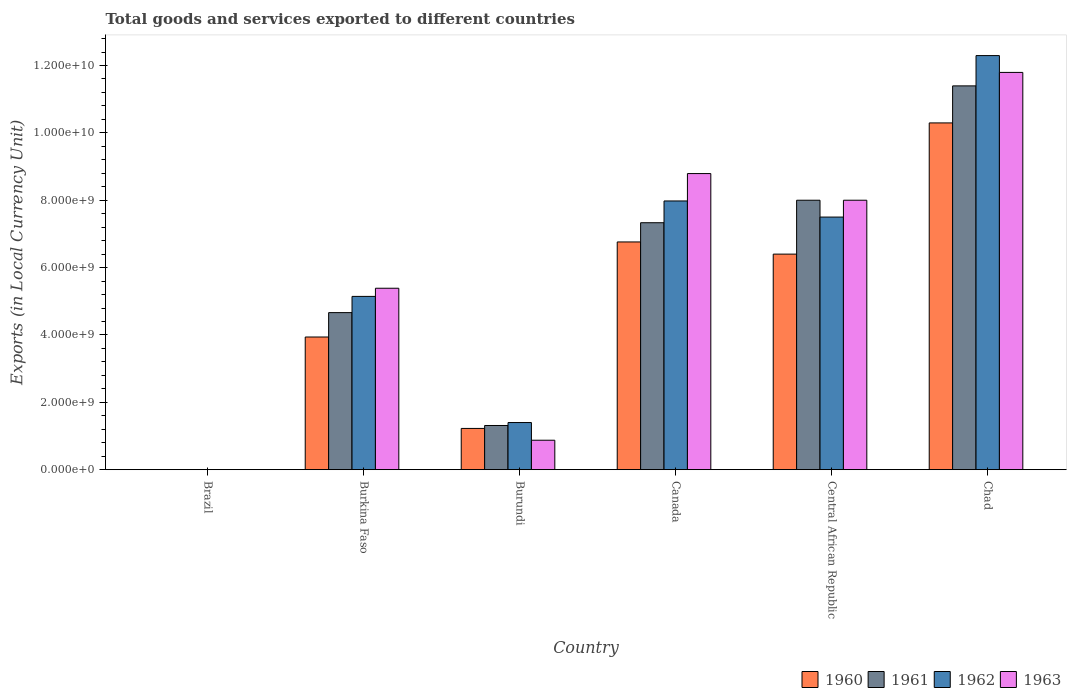How many groups of bars are there?
Give a very brief answer. 6. How many bars are there on the 4th tick from the left?
Give a very brief answer. 4. What is the label of the 2nd group of bars from the left?
Provide a succinct answer. Burkina Faso. What is the Amount of goods and services exports in 1962 in Burkina Faso?
Make the answer very short. 5.14e+09. Across all countries, what is the maximum Amount of goods and services exports in 1961?
Ensure brevity in your answer.  1.14e+1. Across all countries, what is the minimum Amount of goods and services exports in 1960?
Your answer should be compact. 7.27491e-5. In which country was the Amount of goods and services exports in 1962 maximum?
Make the answer very short. Chad. What is the total Amount of goods and services exports in 1963 in the graph?
Ensure brevity in your answer.  3.48e+1. What is the difference between the Amount of goods and services exports in 1963 in Burundi and that in Canada?
Keep it short and to the point. -7.92e+09. What is the difference between the Amount of goods and services exports in 1962 in Canada and the Amount of goods and services exports in 1963 in Burkina Faso?
Give a very brief answer. 2.59e+09. What is the average Amount of goods and services exports in 1963 per country?
Make the answer very short. 5.81e+09. What is the difference between the Amount of goods and services exports of/in 1960 and Amount of goods and services exports of/in 1961 in Canada?
Provide a succinct answer. -5.71e+08. What is the ratio of the Amount of goods and services exports in 1963 in Burkina Faso to that in Burundi?
Your answer should be compact. 6.16. Is the difference between the Amount of goods and services exports in 1960 in Canada and Chad greater than the difference between the Amount of goods and services exports in 1961 in Canada and Chad?
Your answer should be very brief. Yes. What is the difference between the highest and the second highest Amount of goods and services exports in 1961?
Your answer should be very brief. 6.68e+08. What is the difference between the highest and the lowest Amount of goods and services exports in 1960?
Your answer should be compact. 1.03e+1. Is it the case that in every country, the sum of the Amount of goods and services exports in 1961 and Amount of goods and services exports in 1963 is greater than the sum of Amount of goods and services exports in 1960 and Amount of goods and services exports in 1962?
Make the answer very short. No. Is it the case that in every country, the sum of the Amount of goods and services exports in 1961 and Amount of goods and services exports in 1963 is greater than the Amount of goods and services exports in 1960?
Make the answer very short. Yes. How many countries are there in the graph?
Give a very brief answer. 6. What is the difference between two consecutive major ticks on the Y-axis?
Your response must be concise. 2.00e+09. Does the graph contain any zero values?
Offer a very short reply. No. Where does the legend appear in the graph?
Keep it short and to the point. Bottom right. What is the title of the graph?
Your response must be concise. Total goods and services exported to different countries. What is the label or title of the Y-axis?
Your response must be concise. Exports (in Local Currency Unit). What is the Exports (in Local Currency Unit) in 1960 in Brazil?
Your answer should be compact. 7.27491e-5. What is the Exports (in Local Currency Unit) of 1961 in Brazil?
Offer a terse response. 0. What is the Exports (in Local Currency Unit) of 1962 in Brazil?
Your answer should be compact. 0. What is the Exports (in Local Currency Unit) of 1963 in Brazil?
Give a very brief answer. 0. What is the Exports (in Local Currency Unit) in 1960 in Burkina Faso?
Your response must be concise. 3.94e+09. What is the Exports (in Local Currency Unit) in 1961 in Burkina Faso?
Your response must be concise. 4.66e+09. What is the Exports (in Local Currency Unit) in 1962 in Burkina Faso?
Your response must be concise. 5.14e+09. What is the Exports (in Local Currency Unit) in 1963 in Burkina Faso?
Your answer should be compact. 5.39e+09. What is the Exports (in Local Currency Unit) in 1960 in Burundi?
Your response must be concise. 1.22e+09. What is the Exports (in Local Currency Unit) of 1961 in Burundi?
Ensure brevity in your answer.  1.31e+09. What is the Exports (in Local Currency Unit) of 1962 in Burundi?
Give a very brief answer. 1.40e+09. What is the Exports (in Local Currency Unit) in 1963 in Burundi?
Keep it short and to the point. 8.75e+08. What is the Exports (in Local Currency Unit) of 1960 in Canada?
Offer a very short reply. 6.76e+09. What is the Exports (in Local Currency Unit) of 1961 in Canada?
Provide a short and direct response. 7.33e+09. What is the Exports (in Local Currency Unit) of 1962 in Canada?
Your answer should be compact. 7.98e+09. What is the Exports (in Local Currency Unit) in 1963 in Canada?
Give a very brief answer. 8.79e+09. What is the Exports (in Local Currency Unit) of 1960 in Central African Republic?
Give a very brief answer. 6.40e+09. What is the Exports (in Local Currency Unit) in 1961 in Central African Republic?
Your response must be concise. 8.00e+09. What is the Exports (in Local Currency Unit) of 1962 in Central African Republic?
Give a very brief answer. 7.50e+09. What is the Exports (in Local Currency Unit) of 1963 in Central African Republic?
Offer a very short reply. 8.00e+09. What is the Exports (in Local Currency Unit) of 1960 in Chad?
Make the answer very short. 1.03e+1. What is the Exports (in Local Currency Unit) in 1961 in Chad?
Provide a succinct answer. 1.14e+1. What is the Exports (in Local Currency Unit) of 1962 in Chad?
Provide a short and direct response. 1.23e+1. What is the Exports (in Local Currency Unit) in 1963 in Chad?
Provide a succinct answer. 1.18e+1. Across all countries, what is the maximum Exports (in Local Currency Unit) of 1960?
Provide a short and direct response. 1.03e+1. Across all countries, what is the maximum Exports (in Local Currency Unit) of 1961?
Give a very brief answer. 1.14e+1. Across all countries, what is the maximum Exports (in Local Currency Unit) of 1962?
Make the answer very short. 1.23e+1. Across all countries, what is the maximum Exports (in Local Currency Unit) of 1963?
Keep it short and to the point. 1.18e+1. Across all countries, what is the minimum Exports (in Local Currency Unit) of 1960?
Provide a succinct answer. 7.27491e-5. Across all countries, what is the minimum Exports (in Local Currency Unit) of 1961?
Give a very brief answer. 0. Across all countries, what is the minimum Exports (in Local Currency Unit) in 1962?
Keep it short and to the point. 0. Across all countries, what is the minimum Exports (in Local Currency Unit) of 1963?
Make the answer very short. 0. What is the total Exports (in Local Currency Unit) in 1960 in the graph?
Keep it short and to the point. 2.86e+1. What is the total Exports (in Local Currency Unit) in 1961 in the graph?
Offer a very short reply. 3.27e+1. What is the total Exports (in Local Currency Unit) in 1962 in the graph?
Make the answer very short. 3.43e+1. What is the total Exports (in Local Currency Unit) in 1963 in the graph?
Offer a terse response. 3.48e+1. What is the difference between the Exports (in Local Currency Unit) in 1960 in Brazil and that in Burkina Faso?
Offer a terse response. -3.94e+09. What is the difference between the Exports (in Local Currency Unit) in 1961 in Brazil and that in Burkina Faso?
Ensure brevity in your answer.  -4.66e+09. What is the difference between the Exports (in Local Currency Unit) in 1962 in Brazil and that in Burkina Faso?
Your answer should be very brief. -5.14e+09. What is the difference between the Exports (in Local Currency Unit) in 1963 in Brazil and that in Burkina Faso?
Give a very brief answer. -5.39e+09. What is the difference between the Exports (in Local Currency Unit) in 1960 in Brazil and that in Burundi?
Make the answer very short. -1.22e+09. What is the difference between the Exports (in Local Currency Unit) of 1961 in Brazil and that in Burundi?
Your answer should be very brief. -1.31e+09. What is the difference between the Exports (in Local Currency Unit) of 1962 in Brazil and that in Burundi?
Provide a short and direct response. -1.40e+09. What is the difference between the Exports (in Local Currency Unit) of 1963 in Brazil and that in Burundi?
Your answer should be very brief. -8.75e+08. What is the difference between the Exports (in Local Currency Unit) in 1960 in Brazil and that in Canada?
Your answer should be very brief. -6.76e+09. What is the difference between the Exports (in Local Currency Unit) of 1961 in Brazil and that in Canada?
Keep it short and to the point. -7.33e+09. What is the difference between the Exports (in Local Currency Unit) of 1962 in Brazil and that in Canada?
Ensure brevity in your answer.  -7.98e+09. What is the difference between the Exports (in Local Currency Unit) in 1963 in Brazil and that in Canada?
Make the answer very short. -8.79e+09. What is the difference between the Exports (in Local Currency Unit) of 1960 in Brazil and that in Central African Republic?
Your response must be concise. -6.40e+09. What is the difference between the Exports (in Local Currency Unit) in 1961 in Brazil and that in Central African Republic?
Ensure brevity in your answer.  -8.00e+09. What is the difference between the Exports (in Local Currency Unit) of 1962 in Brazil and that in Central African Republic?
Your answer should be very brief. -7.50e+09. What is the difference between the Exports (in Local Currency Unit) of 1963 in Brazil and that in Central African Republic?
Offer a very short reply. -8.00e+09. What is the difference between the Exports (in Local Currency Unit) of 1960 in Brazil and that in Chad?
Your answer should be compact. -1.03e+1. What is the difference between the Exports (in Local Currency Unit) in 1961 in Brazil and that in Chad?
Keep it short and to the point. -1.14e+1. What is the difference between the Exports (in Local Currency Unit) in 1962 in Brazil and that in Chad?
Make the answer very short. -1.23e+1. What is the difference between the Exports (in Local Currency Unit) in 1963 in Brazil and that in Chad?
Provide a succinct answer. -1.18e+1. What is the difference between the Exports (in Local Currency Unit) of 1960 in Burkina Faso and that in Burundi?
Make the answer very short. 2.71e+09. What is the difference between the Exports (in Local Currency Unit) of 1961 in Burkina Faso and that in Burundi?
Keep it short and to the point. 3.35e+09. What is the difference between the Exports (in Local Currency Unit) of 1962 in Burkina Faso and that in Burundi?
Ensure brevity in your answer.  3.74e+09. What is the difference between the Exports (in Local Currency Unit) in 1963 in Burkina Faso and that in Burundi?
Provide a succinct answer. 4.51e+09. What is the difference between the Exports (in Local Currency Unit) in 1960 in Burkina Faso and that in Canada?
Make the answer very short. -2.82e+09. What is the difference between the Exports (in Local Currency Unit) of 1961 in Burkina Faso and that in Canada?
Keep it short and to the point. -2.67e+09. What is the difference between the Exports (in Local Currency Unit) in 1962 in Burkina Faso and that in Canada?
Your answer should be very brief. -2.83e+09. What is the difference between the Exports (in Local Currency Unit) of 1963 in Burkina Faso and that in Canada?
Provide a short and direct response. -3.40e+09. What is the difference between the Exports (in Local Currency Unit) of 1960 in Burkina Faso and that in Central African Republic?
Make the answer very short. -2.46e+09. What is the difference between the Exports (in Local Currency Unit) in 1961 in Burkina Faso and that in Central African Republic?
Your response must be concise. -3.34e+09. What is the difference between the Exports (in Local Currency Unit) in 1962 in Burkina Faso and that in Central African Republic?
Provide a short and direct response. -2.36e+09. What is the difference between the Exports (in Local Currency Unit) in 1963 in Burkina Faso and that in Central African Republic?
Provide a succinct answer. -2.61e+09. What is the difference between the Exports (in Local Currency Unit) of 1960 in Burkina Faso and that in Chad?
Give a very brief answer. -6.36e+09. What is the difference between the Exports (in Local Currency Unit) of 1961 in Burkina Faso and that in Chad?
Ensure brevity in your answer.  -6.73e+09. What is the difference between the Exports (in Local Currency Unit) of 1962 in Burkina Faso and that in Chad?
Offer a terse response. -7.15e+09. What is the difference between the Exports (in Local Currency Unit) in 1963 in Burkina Faso and that in Chad?
Keep it short and to the point. -6.41e+09. What is the difference between the Exports (in Local Currency Unit) of 1960 in Burundi and that in Canada?
Your answer should be compact. -5.54e+09. What is the difference between the Exports (in Local Currency Unit) of 1961 in Burundi and that in Canada?
Ensure brevity in your answer.  -6.02e+09. What is the difference between the Exports (in Local Currency Unit) of 1962 in Burundi and that in Canada?
Offer a very short reply. -6.58e+09. What is the difference between the Exports (in Local Currency Unit) of 1963 in Burundi and that in Canada?
Ensure brevity in your answer.  -7.92e+09. What is the difference between the Exports (in Local Currency Unit) in 1960 in Burundi and that in Central African Republic?
Provide a short and direct response. -5.18e+09. What is the difference between the Exports (in Local Currency Unit) in 1961 in Burundi and that in Central African Republic?
Make the answer very short. -6.69e+09. What is the difference between the Exports (in Local Currency Unit) of 1962 in Burundi and that in Central African Republic?
Offer a very short reply. -6.10e+09. What is the difference between the Exports (in Local Currency Unit) in 1963 in Burundi and that in Central African Republic?
Your answer should be very brief. -7.12e+09. What is the difference between the Exports (in Local Currency Unit) of 1960 in Burundi and that in Chad?
Make the answer very short. -9.07e+09. What is the difference between the Exports (in Local Currency Unit) in 1961 in Burundi and that in Chad?
Offer a very short reply. -1.01e+1. What is the difference between the Exports (in Local Currency Unit) in 1962 in Burundi and that in Chad?
Your answer should be very brief. -1.09e+1. What is the difference between the Exports (in Local Currency Unit) in 1963 in Burundi and that in Chad?
Provide a short and direct response. -1.09e+1. What is the difference between the Exports (in Local Currency Unit) of 1960 in Canada and that in Central African Republic?
Your response must be concise. 3.61e+08. What is the difference between the Exports (in Local Currency Unit) in 1961 in Canada and that in Central African Republic?
Give a very brief answer. -6.68e+08. What is the difference between the Exports (in Local Currency Unit) of 1962 in Canada and that in Central African Republic?
Give a very brief answer. 4.78e+08. What is the difference between the Exports (in Local Currency Unit) in 1963 in Canada and that in Central African Republic?
Keep it short and to the point. 7.91e+08. What is the difference between the Exports (in Local Currency Unit) in 1960 in Canada and that in Chad?
Ensure brevity in your answer.  -3.53e+09. What is the difference between the Exports (in Local Currency Unit) of 1961 in Canada and that in Chad?
Give a very brief answer. -4.06e+09. What is the difference between the Exports (in Local Currency Unit) of 1962 in Canada and that in Chad?
Give a very brief answer. -4.32e+09. What is the difference between the Exports (in Local Currency Unit) of 1963 in Canada and that in Chad?
Your answer should be very brief. -3.00e+09. What is the difference between the Exports (in Local Currency Unit) in 1960 in Central African Republic and that in Chad?
Give a very brief answer. -3.90e+09. What is the difference between the Exports (in Local Currency Unit) of 1961 in Central African Republic and that in Chad?
Give a very brief answer. -3.39e+09. What is the difference between the Exports (in Local Currency Unit) of 1962 in Central African Republic and that in Chad?
Your answer should be very brief. -4.79e+09. What is the difference between the Exports (in Local Currency Unit) in 1963 in Central African Republic and that in Chad?
Ensure brevity in your answer.  -3.79e+09. What is the difference between the Exports (in Local Currency Unit) in 1960 in Brazil and the Exports (in Local Currency Unit) in 1961 in Burkina Faso?
Provide a short and direct response. -4.66e+09. What is the difference between the Exports (in Local Currency Unit) of 1960 in Brazil and the Exports (in Local Currency Unit) of 1962 in Burkina Faso?
Offer a terse response. -5.14e+09. What is the difference between the Exports (in Local Currency Unit) of 1960 in Brazil and the Exports (in Local Currency Unit) of 1963 in Burkina Faso?
Make the answer very short. -5.39e+09. What is the difference between the Exports (in Local Currency Unit) of 1961 in Brazil and the Exports (in Local Currency Unit) of 1962 in Burkina Faso?
Offer a terse response. -5.14e+09. What is the difference between the Exports (in Local Currency Unit) in 1961 in Brazil and the Exports (in Local Currency Unit) in 1963 in Burkina Faso?
Your answer should be very brief. -5.39e+09. What is the difference between the Exports (in Local Currency Unit) of 1962 in Brazil and the Exports (in Local Currency Unit) of 1963 in Burkina Faso?
Provide a succinct answer. -5.39e+09. What is the difference between the Exports (in Local Currency Unit) of 1960 in Brazil and the Exports (in Local Currency Unit) of 1961 in Burundi?
Ensure brevity in your answer.  -1.31e+09. What is the difference between the Exports (in Local Currency Unit) in 1960 in Brazil and the Exports (in Local Currency Unit) in 1962 in Burundi?
Offer a very short reply. -1.40e+09. What is the difference between the Exports (in Local Currency Unit) of 1960 in Brazil and the Exports (in Local Currency Unit) of 1963 in Burundi?
Keep it short and to the point. -8.75e+08. What is the difference between the Exports (in Local Currency Unit) in 1961 in Brazil and the Exports (in Local Currency Unit) in 1962 in Burundi?
Provide a short and direct response. -1.40e+09. What is the difference between the Exports (in Local Currency Unit) of 1961 in Brazil and the Exports (in Local Currency Unit) of 1963 in Burundi?
Offer a terse response. -8.75e+08. What is the difference between the Exports (in Local Currency Unit) in 1962 in Brazil and the Exports (in Local Currency Unit) in 1963 in Burundi?
Offer a very short reply. -8.75e+08. What is the difference between the Exports (in Local Currency Unit) of 1960 in Brazil and the Exports (in Local Currency Unit) of 1961 in Canada?
Your response must be concise. -7.33e+09. What is the difference between the Exports (in Local Currency Unit) in 1960 in Brazil and the Exports (in Local Currency Unit) in 1962 in Canada?
Your answer should be compact. -7.98e+09. What is the difference between the Exports (in Local Currency Unit) in 1960 in Brazil and the Exports (in Local Currency Unit) in 1963 in Canada?
Give a very brief answer. -8.79e+09. What is the difference between the Exports (in Local Currency Unit) in 1961 in Brazil and the Exports (in Local Currency Unit) in 1962 in Canada?
Offer a terse response. -7.98e+09. What is the difference between the Exports (in Local Currency Unit) of 1961 in Brazil and the Exports (in Local Currency Unit) of 1963 in Canada?
Your answer should be compact. -8.79e+09. What is the difference between the Exports (in Local Currency Unit) in 1962 in Brazil and the Exports (in Local Currency Unit) in 1963 in Canada?
Make the answer very short. -8.79e+09. What is the difference between the Exports (in Local Currency Unit) of 1960 in Brazil and the Exports (in Local Currency Unit) of 1961 in Central African Republic?
Ensure brevity in your answer.  -8.00e+09. What is the difference between the Exports (in Local Currency Unit) of 1960 in Brazil and the Exports (in Local Currency Unit) of 1962 in Central African Republic?
Offer a terse response. -7.50e+09. What is the difference between the Exports (in Local Currency Unit) of 1960 in Brazil and the Exports (in Local Currency Unit) of 1963 in Central African Republic?
Keep it short and to the point. -8.00e+09. What is the difference between the Exports (in Local Currency Unit) in 1961 in Brazil and the Exports (in Local Currency Unit) in 1962 in Central African Republic?
Make the answer very short. -7.50e+09. What is the difference between the Exports (in Local Currency Unit) of 1961 in Brazil and the Exports (in Local Currency Unit) of 1963 in Central African Republic?
Offer a very short reply. -8.00e+09. What is the difference between the Exports (in Local Currency Unit) in 1962 in Brazil and the Exports (in Local Currency Unit) in 1963 in Central African Republic?
Offer a very short reply. -8.00e+09. What is the difference between the Exports (in Local Currency Unit) of 1960 in Brazil and the Exports (in Local Currency Unit) of 1961 in Chad?
Offer a very short reply. -1.14e+1. What is the difference between the Exports (in Local Currency Unit) of 1960 in Brazil and the Exports (in Local Currency Unit) of 1962 in Chad?
Keep it short and to the point. -1.23e+1. What is the difference between the Exports (in Local Currency Unit) in 1960 in Brazil and the Exports (in Local Currency Unit) in 1963 in Chad?
Provide a succinct answer. -1.18e+1. What is the difference between the Exports (in Local Currency Unit) of 1961 in Brazil and the Exports (in Local Currency Unit) of 1962 in Chad?
Make the answer very short. -1.23e+1. What is the difference between the Exports (in Local Currency Unit) in 1961 in Brazil and the Exports (in Local Currency Unit) in 1963 in Chad?
Ensure brevity in your answer.  -1.18e+1. What is the difference between the Exports (in Local Currency Unit) of 1962 in Brazil and the Exports (in Local Currency Unit) of 1963 in Chad?
Provide a short and direct response. -1.18e+1. What is the difference between the Exports (in Local Currency Unit) in 1960 in Burkina Faso and the Exports (in Local Currency Unit) in 1961 in Burundi?
Your response must be concise. 2.63e+09. What is the difference between the Exports (in Local Currency Unit) in 1960 in Burkina Faso and the Exports (in Local Currency Unit) in 1962 in Burundi?
Your answer should be compact. 2.54e+09. What is the difference between the Exports (in Local Currency Unit) in 1960 in Burkina Faso and the Exports (in Local Currency Unit) in 1963 in Burundi?
Give a very brief answer. 3.06e+09. What is the difference between the Exports (in Local Currency Unit) of 1961 in Burkina Faso and the Exports (in Local Currency Unit) of 1962 in Burundi?
Your answer should be compact. 3.26e+09. What is the difference between the Exports (in Local Currency Unit) in 1961 in Burkina Faso and the Exports (in Local Currency Unit) in 1963 in Burundi?
Keep it short and to the point. 3.79e+09. What is the difference between the Exports (in Local Currency Unit) of 1962 in Burkina Faso and the Exports (in Local Currency Unit) of 1963 in Burundi?
Your response must be concise. 4.27e+09. What is the difference between the Exports (in Local Currency Unit) of 1960 in Burkina Faso and the Exports (in Local Currency Unit) of 1961 in Canada?
Keep it short and to the point. -3.39e+09. What is the difference between the Exports (in Local Currency Unit) in 1960 in Burkina Faso and the Exports (in Local Currency Unit) in 1962 in Canada?
Provide a succinct answer. -4.04e+09. What is the difference between the Exports (in Local Currency Unit) in 1960 in Burkina Faso and the Exports (in Local Currency Unit) in 1963 in Canada?
Ensure brevity in your answer.  -4.85e+09. What is the difference between the Exports (in Local Currency Unit) in 1961 in Burkina Faso and the Exports (in Local Currency Unit) in 1962 in Canada?
Give a very brief answer. -3.31e+09. What is the difference between the Exports (in Local Currency Unit) of 1961 in Burkina Faso and the Exports (in Local Currency Unit) of 1963 in Canada?
Your response must be concise. -4.13e+09. What is the difference between the Exports (in Local Currency Unit) in 1962 in Burkina Faso and the Exports (in Local Currency Unit) in 1963 in Canada?
Offer a terse response. -3.65e+09. What is the difference between the Exports (in Local Currency Unit) of 1960 in Burkina Faso and the Exports (in Local Currency Unit) of 1961 in Central African Republic?
Offer a terse response. -4.06e+09. What is the difference between the Exports (in Local Currency Unit) of 1960 in Burkina Faso and the Exports (in Local Currency Unit) of 1962 in Central African Republic?
Offer a very short reply. -3.56e+09. What is the difference between the Exports (in Local Currency Unit) of 1960 in Burkina Faso and the Exports (in Local Currency Unit) of 1963 in Central African Republic?
Offer a very short reply. -4.06e+09. What is the difference between the Exports (in Local Currency Unit) of 1961 in Burkina Faso and the Exports (in Local Currency Unit) of 1962 in Central African Republic?
Make the answer very short. -2.84e+09. What is the difference between the Exports (in Local Currency Unit) of 1961 in Burkina Faso and the Exports (in Local Currency Unit) of 1963 in Central African Republic?
Make the answer very short. -3.34e+09. What is the difference between the Exports (in Local Currency Unit) of 1962 in Burkina Faso and the Exports (in Local Currency Unit) of 1963 in Central African Republic?
Make the answer very short. -2.86e+09. What is the difference between the Exports (in Local Currency Unit) in 1960 in Burkina Faso and the Exports (in Local Currency Unit) in 1961 in Chad?
Make the answer very short. -7.46e+09. What is the difference between the Exports (in Local Currency Unit) of 1960 in Burkina Faso and the Exports (in Local Currency Unit) of 1962 in Chad?
Offer a very short reply. -8.35e+09. What is the difference between the Exports (in Local Currency Unit) in 1960 in Burkina Faso and the Exports (in Local Currency Unit) in 1963 in Chad?
Make the answer very short. -7.86e+09. What is the difference between the Exports (in Local Currency Unit) in 1961 in Burkina Faso and the Exports (in Local Currency Unit) in 1962 in Chad?
Your answer should be very brief. -7.63e+09. What is the difference between the Exports (in Local Currency Unit) in 1961 in Burkina Faso and the Exports (in Local Currency Unit) in 1963 in Chad?
Offer a terse response. -7.13e+09. What is the difference between the Exports (in Local Currency Unit) of 1962 in Burkina Faso and the Exports (in Local Currency Unit) of 1963 in Chad?
Your answer should be compact. -6.65e+09. What is the difference between the Exports (in Local Currency Unit) of 1960 in Burundi and the Exports (in Local Currency Unit) of 1961 in Canada?
Give a very brief answer. -6.11e+09. What is the difference between the Exports (in Local Currency Unit) in 1960 in Burundi and the Exports (in Local Currency Unit) in 1962 in Canada?
Offer a very short reply. -6.75e+09. What is the difference between the Exports (in Local Currency Unit) of 1960 in Burundi and the Exports (in Local Currency Unit) of 1963 in Canada?
Ensure brevity in your answer.  -7.57e+09. What is the difference between the Exports (in Local Currency Unit) in 1961 in Burundi and the Exports (in Local Currency Unit) in 1962 in Canada?
Keep it short and to the point. -6.67e+09. What is the difference between the Exports (in Local Currency Unit) of 1961 in Burundi and the Exports (in Local Currency Unit) of 1963 in Canada?
Give a very brief answer. -7.48e+09. What is the difference between the Exports (in Local Currency Unit) in 1962 in Burundi and the Exports (in Local Currency Unit) in 1963 in Canada?
Your response must be concise. -7.39e+09. What is the difference between the Exports (in Local Currency Unit) of 1960 in Burundi and the Exports (in Local Currency Unit) of 1961 in Central African Republic?
Provide a short and direct response. -6.78e+09. What is the difference between the Exports (in Local Currency Unit) of 1960 in Burundi and the Exports (in Local Currency Unit) of 1962 in Central African Republic?
Your answer should be compact. -6.28e+09. What is the difference between the Exports (in Local Currency Unit) in 1960 in Burundi and the Exports (in Local Currency Unit) in 1963 in Central African Republic?
Your answer should be compact. -6.78e+09. What is the difference between the Exports (in Local Currency Unit) of 1961 in Burundi and the Exports (in Local Currency Unit) of 1962 in Central African Republic?
Your response must be concise. -6.19e+09. What is the difference between the Exports (in Local Currency Unit) of 1961 in Burundi and the Exports (in Local Currency Unit) of 1963 in Central African Republic?
Provide a short and direct response. -6.69e+09. What is the difference between the Exports (in Local Currency Unit) of 1962 in Burundi and the Exports (in Local Currency Unit) of 1963 in Central African Republic?
Make the answer very short. -6.60e+09. What is the difference between the Exports (in Local Currency Unit) in 1960 in Burundi and the Exports (in Local Currency Unit) in 1961 in Chad?
Make the answer very short. -1.02e+1. What is the difference between the Exports (in Local Currency Unit) in 1960 in Burundi and the Exports (in Local Currency Unit) in 1962 in Chad?
Your response must be concise. -1.11e+1. What is the difference between the Exports (in Local Currency Unit) of 1960 in Burundi and the Exports (in Local Currency Unit) of 1963 in Chad?
Make the answer very short. -1.06e+1. What is the difference between the Exports (in Local Currency Unit) in 1961 in Burundi and the Exports (in Local Currency Unit) in 1962 in Chad?
Give a very brief answer. -1.10e+1. What is the difference between the Exports (in Local Currency Unit) of 1961 in Burundi and the Exports (in Local Currency Unit) of 1963 in Chad?
Keep it short and to the point. -1.05e+1. What is the difference between the Exports (in Local Currency Unit) in 1962 in Burundi and the Exports (in Local Currency Unit) in 1963 in Chad?
Ensure brevity in your answer.  -1.04e+1. What is the difference between the Exports (in Local Currency Unit) of 1960 in Canada and the Exports (in Local Currency Unit) of 1961 in Central African Republic?
Give a very brief answer. -1.24e+09. What is the difference between the Exports (in Local Currency Unit) of 1960 in Canada and the Exports (in Local Currency Unit) of 1962 in Central African Republic?
Offer a terse response. -7.39e+08. What is the difference between the Exports (in Local Currency Unit) in 1960 in Canada and the Exports (in Local Currency Unit) in 1963 in Central African Republic?
Your response must be concise. -1.24e+09. What is the difference between the Exports (in Local Currency Unit) of 1961 in Canada and the Exports (in Local Currency Unit) of 1962 in Central African Republic?
Your response must be concise. -1.68e+08. What is the difference between the Exports (in Local Currency Unit) of 1961 in Canada and the Exports (in Local Currency Unit) of 1963 in Central African Republic?
Offer a terse response. -6.68e+08. What is the difference between the Exports (in Local Currency Unit) of 1962 in Canada and the Exports (in Local Currency Unit) of 1963 in Central African Republic?
Offer a terse response. -2.17e+07. What is the difference between the Exports (in Local Currency Unit) in 1960 in Canada and the Exports (in Local Currency Unit) in 1961 in Chad?
Your answer should be compact. -4.63e+09. What is the difference between the Exports (in Local Currency Unit) of 1960 in Canada and the Exports (in Local Currency Unit) of 1962 in Chad?
Ensure brevity in your answer.  -5.53e+09. What is the difference between the Exports (in Local Currency Unit) in 1960 in Canada and the Exports (in Local Currency Unit) in 1963 in Chad?
Make the answer very short. -5.03e+09. What is the difference between the Exports (in Local Currency Unit) of 1961 in Canada and the Exports (in Local Currency Unit) of 1962 in Chad?
Keep it short and to the point. -4.96e+09. What is the difference between the Exports (in Local Currency Unit) in 1961 in Canada and the Exports (in Local Currency Unit) in 1963 in Chad?
Offer a terse response. -4.46e+09. What is the difference between the Exports (in Local Currency Unit) of 1962 in Canada and the Exports (in Local Currency Unit) of 1963 in Chad?
Provide a succinct answer. -3.82e+09. What is the difference between the Exports (in Local Currency Unit) of 1960 in Central African Republic and the Exports (in Local Currency Unit) of 1961 in Chad?
Give a very brief answer. -4.99e+09. What is the difference between the Exports (in Local Currency Unit) of 1960 in Central African Republic and the Exports (in Local Currency Unit) of 1962 in Chad?
Give a very brief answer. -5.89e+09. What is the difference between the Exports (in Local Currency Unit) in 1960 in Central African Republic and the Exports (in Local Currency Unit) in 1963 in Chad?
Offer a very short reply. -5.39e+09. What is the difference between the Exports (in Local Currency Unit) in 1961 in Central African Republic and the Exports (in Local Currency Unit) in 1962 in Chad?
Give a very brief answer. -4.29e+09. What is the difference between the Exports (in Local Currency Unit) of 1961 in Central African Republic and the Exports (in Local Currency Unit) of 1963 in Chad?
Your answer should be very brief. -3.79e+09. What is the difference between the Exports (in Local Currency Unit) of 1962 in Central African Republic and the Exports (in Local Currency Unit) of 1963 in Chad?
Ensure brevity in your answer.  -4.29e+09. What is the average Exports (in Local Currency Unit) of 1960 per country?
Your answer should be very brief. 4.77e+09. What is the average Exports (in Local Currency Unit) of 1961 per country?
Offer a terse response. 5.45e+09. What is the average Exports (in Local Currency Unit) of 1962 per country?
Keep it short and to the point. 5.72e+09. What is the average Exports (in Local Currency Unit) in 1963 per country?
Give a very brief answer. 5.81e+09. What is the difference between the Exports (in Local Currency Unit) in 1960 and Exports (in Local Currency Unit) in 1963 in Brazil?
Make the answer very short. -0. What is the difference between the Exports (in Local Currency Unit) in 1961 and Exports (in Local Currency Unit) in 1963 in Brazil?
Your response must be concise. -0. What is the difference between the Exports (in Local Currency Unit) in 1962 and Exports (in Local Currency Unit) in 1963 in Brazil?
Offer a terse response. -0. What is the difference between the Exports (in Local Currency Unit) in 1960 and Exports (in Local Currency Unit) in 1961 in Burkina Faso?
Provide a succinct answer. -7.24e+08. What is the difference between the Exports (in Local Currency Unit) of 1960 and Exports (in Local Currency Unit) of 1962 in Burkina Faso?
Ensure brevity in your answer.  -1.21e+09. What is the difference between the Exports (in Local Currency Unit) of 1960 and Exports (in Local Currency Unit) of 1963 in Burkina Faso?
Provide a succinct answer. -1.45e+09. What is the difference between the Exports (in Local Currency Unit) of 1961 and Exports (in Local Currency Unit) of 1962 in Burkina Faso?
Keep it short and to the point. -4.81e+08. What is the difference between the Exports (in Local Currency Unit) in 1961 and Exports (in Local Currency Unit) in 1963 in Burkina Faso?
Offer a very short reply. -7.23e+08. What is the difference between the Exports (in Local Currency Unit) in 1962 and Exports (in Local Currency Unit) in 1963 in Burkina Faso?
Provide a succinct answer. -2.42e+08. What is the difference between the Exports (in Local Currency Unit) in 1960 and Exports (in Local Currency Unit) in 1961 in Burundi?
Make the answer very short. -8.75e+07. What is the difference between the Exports (in Local Currency Unit) of 1960 and Exports (in Local Currency Unit) of 1962 in Burundi?
Give a very brief answer. -1.75e+08. What is the difference between the Exports (in Local Currency Unit) of 1960 and Exports (in Local Currency Unit) of 1963 in Burundi?
Make the answer very short. 3.50e+08. What is the difference between the Exports (in Local Currency Unit) of 1961 and Exports (in Local Currency Unit) of 1962 in Burundi?
Provide a short and direct response. -8.75e+07. What is the difference between the Exports (in Local Currency Unit) of 1961 and Exports (in Local Currency Unit) of 1963 in Burundi?
Ensure brevity in your answer.  4.38e+08. What is the difference between the Exports (in Local Currency Unit) of 1962 and Exports (in Local Currency Unit) of 1963 in Burundi?
Offer a very short reply. 5.25e+08. What is the difference between the Exports (in Local Currency Unit) of 1960 and Exports (in Local Currency Unit) of 1961 in Canada?
Ensure brevity in your answer.  -5.71e+08. What is the difference between the Exports (in Local Currency Unit) of 1960 and Exports (in Local Currency Unit) of 1962 in Canada?
Offer a very short reply. -1.22e+09. What is the difference between the Exports (in Local Currency Unit) of 1960 and Exports (in Local Currency Unit) of 1963 in Canada?
Make the answer very short. -2.03e+09. What is the difference between the Exports (in Local Currency Unit) in 1961 and Exports (in Local Currency Unit) in 1962 in Canada?
Offer a terse response. -6.46e+08. What is the difference between the Exports (in Local Currency Unit) in 1961 and Exports (in Local Currency Unit) in 1963 in Canada?
Provide a succinct answer. -1.46e+09. What is the difference between the Exports (in Local Currency Unit) in 1962 and Exports (in Local Currency Unit) in 1963 in Canada?
Offer a very short reply. -8.13e+08. What is the difference between the Exports (in Local Currency Unit) of 1960 and Exports (in Local Currency Unit) of 1961 in Central African Republic?
Provide a short and direct response. -1.60e+09. What is the difference between the Exports (in Local Currency Unit) in 1960 and Exports (in Local Currency Unit) in 1962 in Central African Republic?
Give a very brief answer. -1.10e+09. What is the difference between the Exports (in Local Currency Unit) in 1960 and Exports (in Local Currency Unit) in 1963 in Central African Republic?
Your answer should be compact. -1.60e+09. What is the difference between the Exports (in Local Currency Unit) in 1961 and Exports (in Local Currency Unit) in 1962 in Central African Republic?
Your answer should be compact. 5.00e+08. What is the difference between the Exports (in Local Currency Unit) of 1962 and Exports (in Local Currency Unit) of 1963 in Central African Republic?
Offer a terse response. -5.00e+08. What is the difference between the Exports (in Local Currency Unit) of 1960 and Exports (in Local Currency Unit) of 1961 in Chad?
Your answer should be very brief. -1.10e+09. What is the difference between the Exports (in Local Currency Unit) in 1960 and Exports (in Local Currency Unit) in 1962 in Chad?
Your answer should be very brief. -2.00e+09. What is the difference between the Exports (in Local Currency Unit) of 1960 and Exports (in Local Currency Unit) of 1963 in Chad?
Offer a terse response. -1.50e+09. What is the difference between the Exports (in Local Currency Unit) of 1961 and Exports (in Local Currency Unit) of 1962 in Chad?
Your answer should be compact. -9.00e+08. What is the difference between the Exports (in Local Currency Unit) in 1961 and Exports (in Local Currency Unit) in 1963 in Chad?
Provide a succinct answer. -4.00e+08. What is the difference between the Exports (in Local Currency Unit) in 1962 and Exports (in Local Currency Unit) in 1963 in Chad?
Offer a very short reply. 5.00e+08. What is the ratio of the Exports (in Local Currency Unit) of 1962 in Brazil to that in Burkina Faso?
Make the answer very short. 0. What is the ratio of the Exports (in Local Currency Unit) of 1960 in Brazil to that in Burundi?
Your answer should be very brief. 0. What is the ratio of the Exports (in Local Currency Unit) of 1961 in Brazil to that in Burundi?
Keep it short and to the point. 0. What is the ratio of the Exports (in Local Currency Unit) of 1960 in Brazil to that in Canada?
Provide a short and direct response. 0. What is the ratio of the Exports (in Local Currency Unit) of 1961 in Brazil to that in Canada?
Provide a short and direct response. 0. What is the ratio of the Exports (in Local Currency Unit) of 1962 in Brazil to that in Canada?
Your response must be concise. 0. What is the ratio of the Exports (in Local Currency Unit) in 1960 in Brazil to that in Central African Republic?
Ensure brevity in your answer.  0. What is the ratio of the Exports (in Local Currency Unit) of 1962 in Brazil to that in Central African Republic?
Your answer should be compact. 0. What is the ratio of the Exports (in Local Currency Unit) of 1963 in Brazil to that in Central African Republic?
Ensure brevity in your answer.  0. What is the ratio of the Exports (in Local Currency Unit) of 1960 in Brazil to that in Chad?
Your answer should be very brief. 0. What is the ratio of the Exports (in Local Currency Unit) of 1963 in Brazil to that in Chad?
Ensure brevity in your answer.  0. What is the ratio of the Exports (in Local Currency Unit) of 1960 in Burkina Faso to that in Burundi?
Give a very brief answer. 3.22. What is the ratio of the Exports (in Local Currency Unit) in 1961 in Burkina Faso to that in Burundi?
Provide a succinct answer. 3.55. What is the ratio of the Exports (in Local Currency Unit) in 1962 in Burkina Faso to that in Burundi?
Your response must be concise. 3.67. What is the ratio of the Exports (in Local Currency Unit) in 1963 in Burkina Faso to that in Burundi?
Ensure brevity in your answer.  6.16. What is the ratio of the Exports (in Local Currency Unit) of 1960 in Burkina Faso to that in Canada?
Provide a succinct answer. 0.58. What is the ratio of the Exports (in Local Currency Unit) in 1961 in Burkina Faso to that in Canada?
Your response must be concise. 0.64. What is the ratio of the Exports (in Local Currency Unit) in 1962 in Burkina Faso to that in Canada?
Provide a succinct answer. 0.64. What is the ratio of the Exports (in Local Currency Unit) of 1963 in Burkina Faso to that in Canada?
Ensure brevity in your answer.  0.61. What is the ratio of the Exports (in Local Currency Unit) of 1960 in Burkina Faso to that in Central African Republic?
Provide a short and direct response. 0.62. What is the ratio of the Exports (in Local Currency Unit) of 1961 in Burkina Faso to that in Central African Republic?
Offer a very short reply. 0.58. What is the ratio of the Exports (in Local Currency Unit) in 1962 in Burkina Faso to that in Central African Republic?
Ensure brevity in your answer.  0.69. What is the ratio of the Exports (in Local Currency Unit) of 1963 in Burkina Faso to that in Central African Republic?
Your answer should be very brief. 0.67. What is the ratio of the Exports (in Local Currency Unit) in 1960 in Burkina Faso to that in Chad?
Your response must be concise. 0.38. What is the ratio of the Exports (in Local Currency Unit) of 1961 in Burkina Faso to that in Chad?
Ensure brevity in your answer.  0.41. What is the ratio of the Exports (in Local Currency Unit) of 1962 in Burkina Faso to that in Chad?
Your response must be concise. 0.42. What is the ratio of the Exports (in Local Currency Unit) in 1963 in Burkina Faso to that in Chad?
Offer a terse response. 0.46. What is the ratio of the Exports (in Local Currency Unit) of 1960 in Burundi to that in Canada?
Provide a succinct answer. 0.18. What is the ratio of the Exports (in Local Currency Unit) of 1961 in Burundi to that in Canada?
Your answer should be very brief. 0.18. What is the ratio of the Exports (in Local Currency Unit) in 1962 in Burundi to that in Canada?
Make the answer very short. 0.18. What is the ratio of the Exports (in Local Currency Unit) of 1963 in Burundi to that in Canada?
Make the answer very short. 0.1. What is the ratio of the Exports (in Local Currency Unit) of 1960 in Burundi to that in Central African Republic?
Offer a terse response. 0.19. What is the ratio of the Exports (in Local Currency Unit) of 1961 in Burundi to that in Central African Republic?
Ensure brevity in your answer.  0.16. What is the ratio of the Exports (in Local Currency Unit) in 1962 in Burundi to that in Central African Republic?
Provide a short and direct response. 0.19. What is the ratio of the Exports (in Local Currency Unit) in 1963 in Burundi to that in Central African Republic?
Offer a very short reply. 0.11. What is the ratio of the Exports (in Local Currency Unit) of 1960 in Burundi to that in Chad?
Keep it short and to the point. 0.12. What is the ratio of the Exports (in Local Currency Unit) in 1961 in Burundi to that in Chad?
Keep it short and to the point. 0.12. What is the ratio of the Exports (in Local Currency Unit) of 1962 in Burundi to that in Chad?
Give a very brief answer. 0.11. What is the ratio of the Exports (in Local Currency Unit) in 1963 in Burundi to that in Chad?
Give a very brief answer. 0.07. What is the ratio of the Exports (in Local Currency Unit) of 1960 in Canada to that in Central African Republic?
Provide a short and direct response. 1.06. What is the ratio of the Exports (in Local Currency Unit) in 1961 in Canada to that in Central African Republic?
Provide a succinct answer. 0.92. What is the ratio of the Exports (in Local Currency Unit) in 1962 in Canada to that in Central African Republic?
Offer a terse response. 1.06. What is the ratio of the Exports (in Local Currency Unit) in 1963 in Canada to that in Central African Republic?
Ensure brevity in your answer.  1.1. What is the ratio of the Exports (in Local Currency Unit) in 1960 in Canada to that in Chad?
Your answer should be compact. 0.66. What is the ratio of the Exports (in Local Currency Unit) in 1961 in Canada to that in Chad?
Give a very brief answer. 0.64. What is the ratio of the Exports (in Local Currency Unit) of 1962 in Canada to that in Chad?
Your answer should be compact. 0.65. What is the ratio of the Exports (in Local Currency Unit) in 1963 in Canada to that in Chad?
Your answer should be compact. 0.75. What is the ratio of the Exports (in Local Currency Unit) of 1960 in Central African Republic to that in Chad?
Provide a succinct answer. 0.62. What is the ratio of the Exports (in Local Currency Unit) in 1961 in Central African Republic to that in Chad?
Your answer should be very brief. 0.7. What is the ratio of the Exports (in Local Currency Unit) in 1962 in Central African Republic to that in Chad?
Your answer should be compact. 0.61. What is the ratio of the Exports (in Local Currency Unit) of 1963 in Central African Republic to that in Chad?
Provide a short and direct response. 0.68. What is the difference between the highest and the second highest Exports (in Local Currency Unit) of 1960?
Provide a short and direct response. 3.53e+09. What is the difference between the highest and the second highest Exports (in Local Currency Unit) in 1961?
Provide a short and direct response. 3.39e+09. What is the difference between the highest and the second highest Exports (in Local Currency Unit) in 1962?
Keep it short and to the point. 4.32e+09. What is the difference between the highest and the second highest Exports (in Local Currency Unit) in 1963?
Provide a succinct answer. 3.00e+09. What is the difference between the highest and the lowest Exports (in Local Currency Unit) in 1960?
Give a very brief answer. 1.03e+1. What is the difference between the highest and the lowest Exports (in Local Currency Unit) of 1961?
Your answer should be very brief. 1.14e+1. What is the difference between the highest and the lowest Exports (in Local Currency Unit) in 1962?
Your answer should be very brief. 1.23e+1. What is the difference between the highest and the lowest Exports (in Local Currency Unit) in 1963?
Make the answer very short. 1.18e+1. 